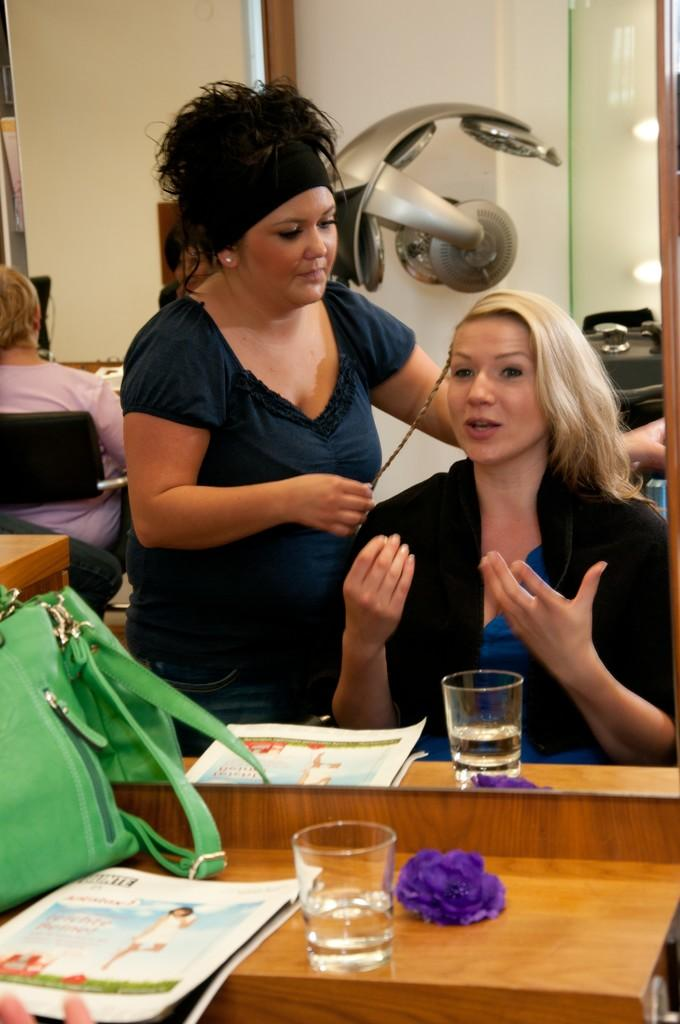How many people are in the image? There are two ladies in the image. What are the ladies doing in the image? The ladies are sitting on chairs in the image. What is behind the ladies in the image? The ladies are in front of a mirror in the image. What objects can be seen on the mirror desk? There is a bag, a paper, and a glass on the mirror desk in the image. What type of birds can be seen flying in the image? There are no birds visible in the image. What insurance policy do the ladies have in the image? There is no mention of insurance in the image. 